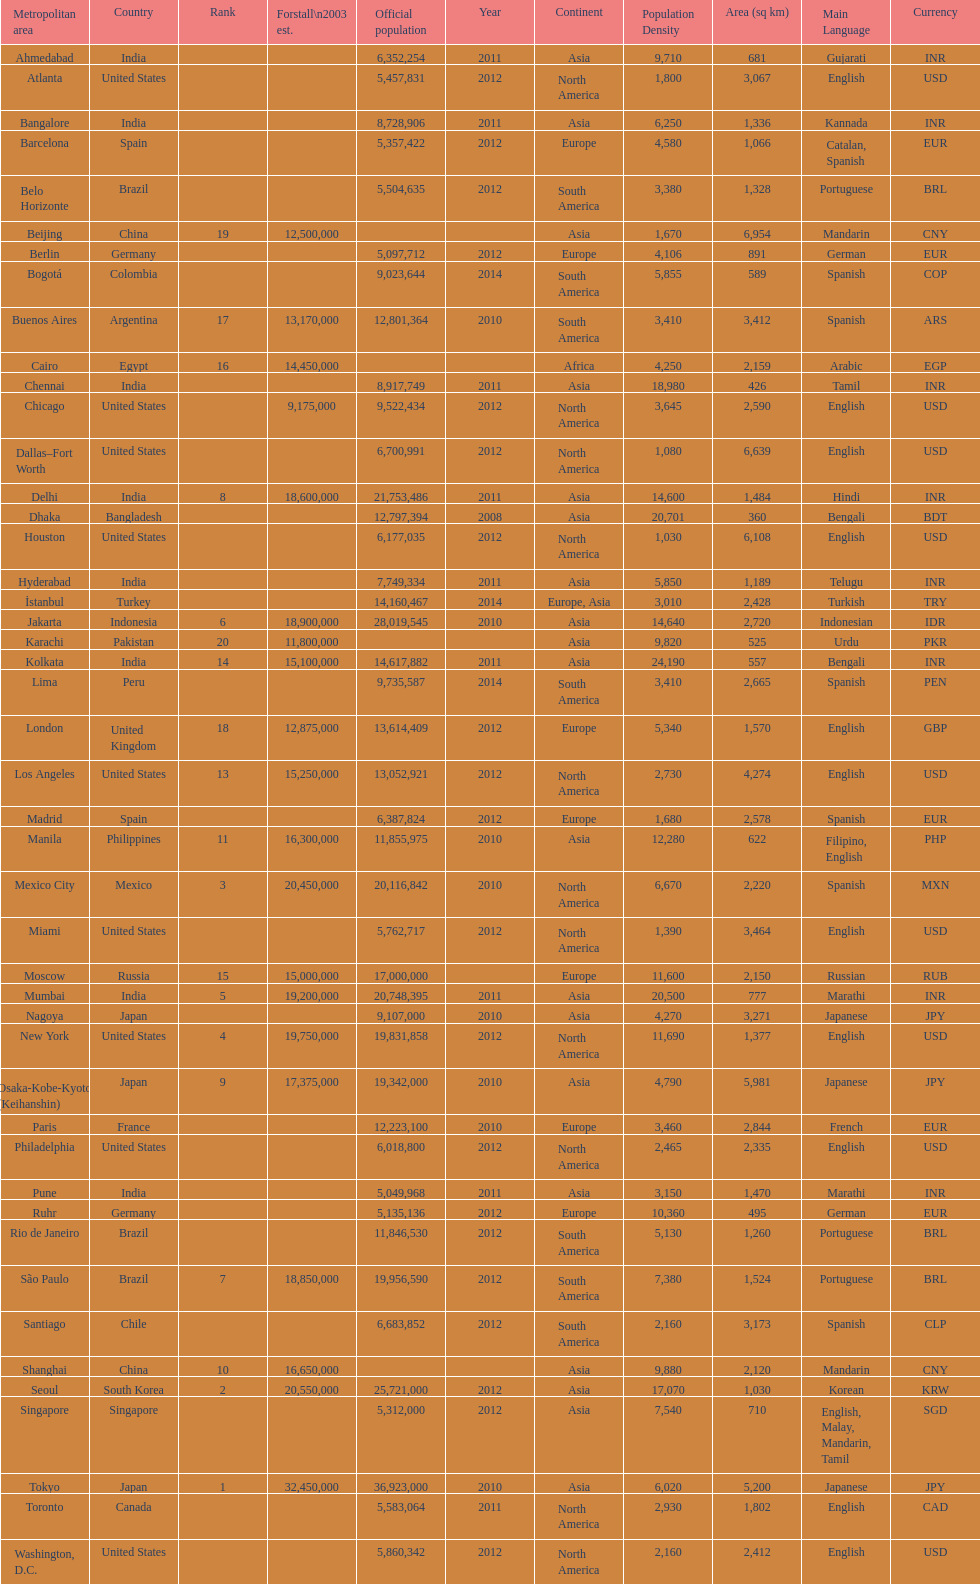What city was ranked first in 2003? Tokyo. 